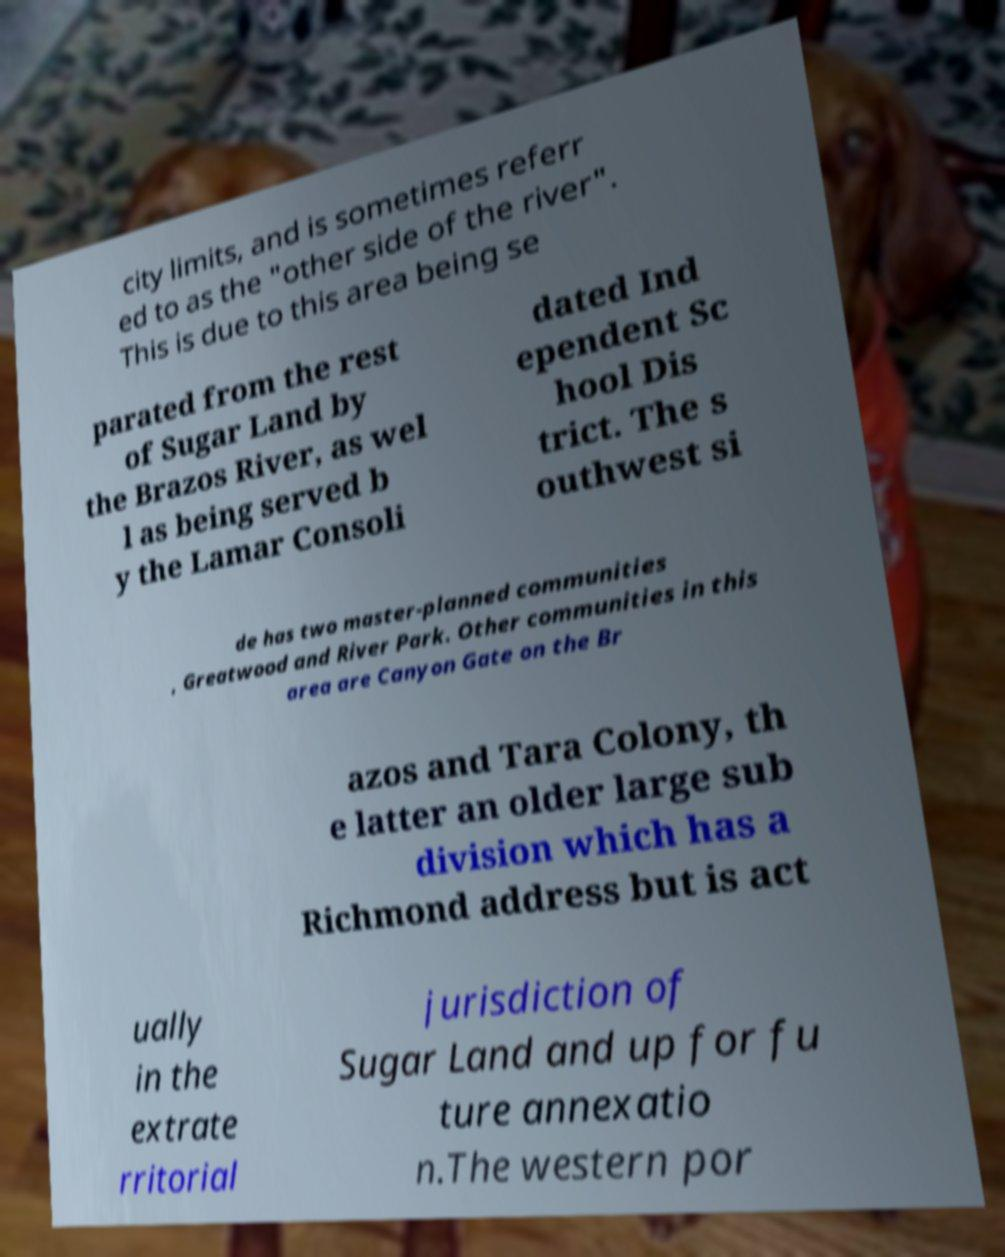Can you accurately transcribe the text from the provided image for me? city limits, and is sometimes referr ed to as the "other side of the river". This is due to this area being se parated from the rest of Sugar Land by the Brazos River, as wel l as being served b y the Lamar Consoli dated Ind ependent Sc hool Dis trict. The s outhwest si de has two master-planned communities , Greatwood and River Park. Other communities in this area are Canyon Gate on the Br azos and Tara Colony, th e latter an older large sub division which has a Richmond address but is act ually in the extrate rritorial jurisdiction of Sugar Land and up for fu ture annexatio n.The western por 